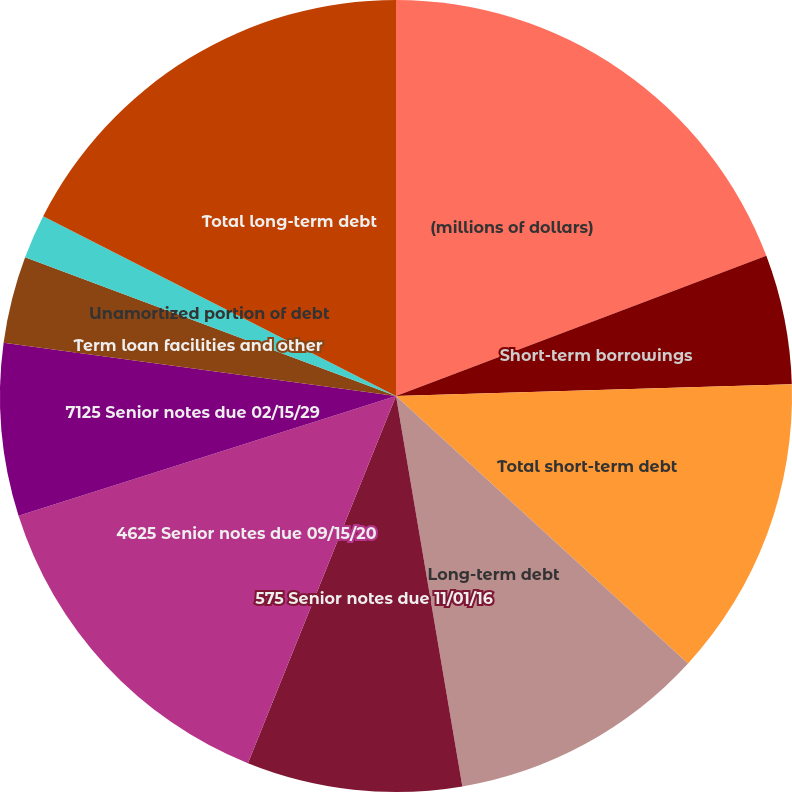Convert chart. <chart><loc_0><loc_0><loc_500><loc_500><pie_chart><fcel>(millions of dollars)<fcel>Short-term borrowings<fcel>Total short-term debt<fcel>Long-term debt<fcel>575 Senior notes due 11/01/16<fcel>4625 Senior notes due 09/15/20<fcel>7125 Senior notes due 02/15/29<fcel>Term loan facilities and other<fcel>Unamortized portion of debt<fcel>Total long-term debt<nl><fcel>19.24%<fcel>5.29%<fcel>12.27%<fcel>10.52%<fcel>8.78%<fcel>14.01%<fcel>7.04%<fcel>3.55%<fcel>1.8%<fcel>17.5%<nl></chart> 